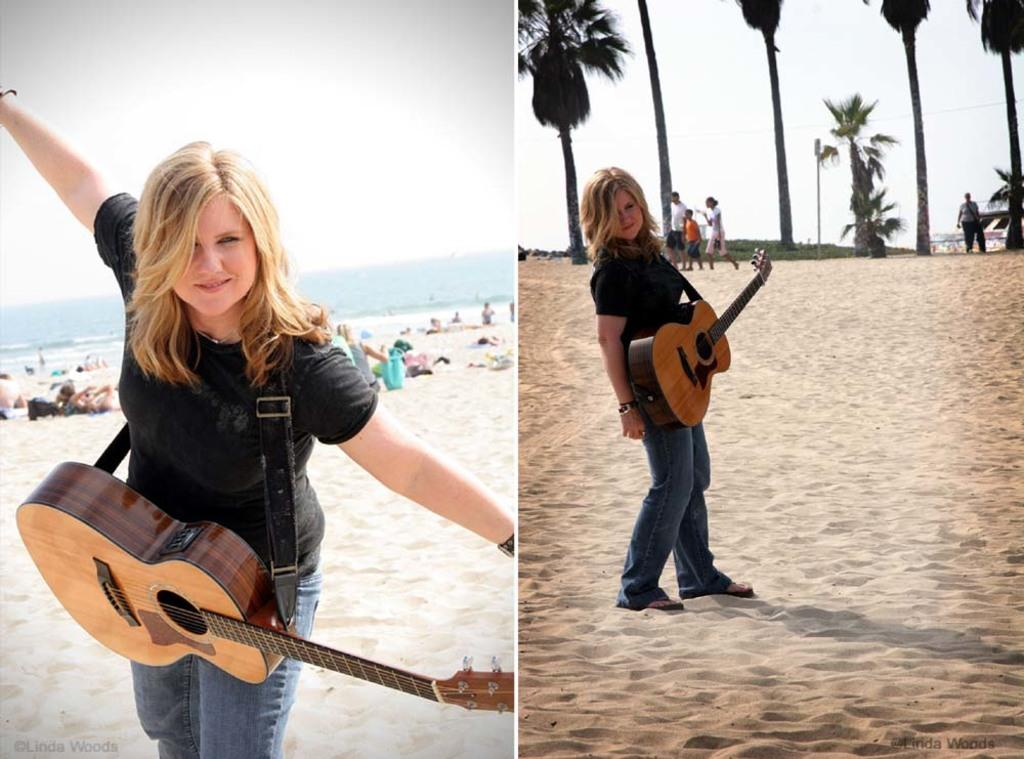What is the woman doing in the image? A woman is posing for a camera in the image. What is the woman wearing in the image? The woman is wearing a guitar in the image. Where does the scene take place? The scene takes place at a beach. What is the woman wearing on her upper body? The woman is wearing a black T-shirt in the image. What is the woman wearing on her lower body? The woman is wearing denim pants in the image. What can be seen in the background of the image? There is a sea in the background of the image. What is the condition of the sky in the image? The sky is clear in the image. What type of bat is flying in the background of the image? There is no bat present in the image; it takes place at a beach with a clear sky and sea in the background. 